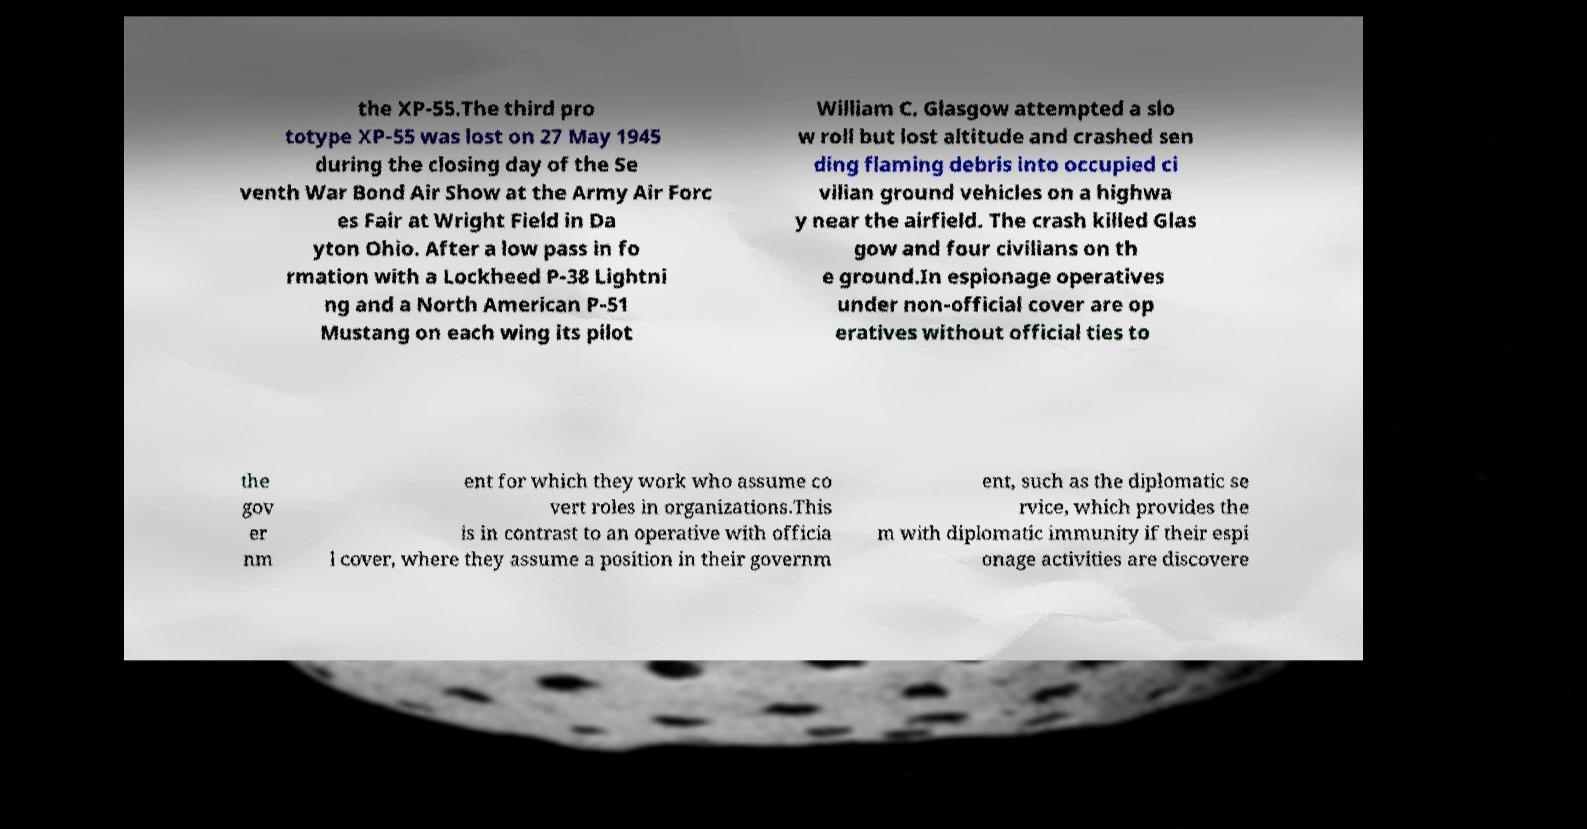What messages or text are displayed in this image? I need them in a readable, typed format. the XP-55.The third pro totype XP-55 was lost on 27 May 1945 during the closing day of the Se venth War Bond Air Show at the Army Air Forc es Fair at Wright Field in Da yton Ohio. After a low pass in fo rmation with a Lockheed P-38 Lightni ng and a North American P-51 Mustang on each wing its pilot William C. Glasgow attempted a slo w roll but lost altitude and crashed sen ding flaming debris into occupied ci vilian ground vehicles on a highwa y near the airfield. The crash killed Glas gow and four civilians on th e ground.In espionage operatives under non-official cover are op eratives without official ties to the gov er nm ent for which they work who assume co vert roles in organizations.This is in contrast to an operative with officia l cover, where they assume a position in their governm ent, such as the diplomatic se rvice, which provides the m with diplomatic immunity if their espi onage activities are discovere 